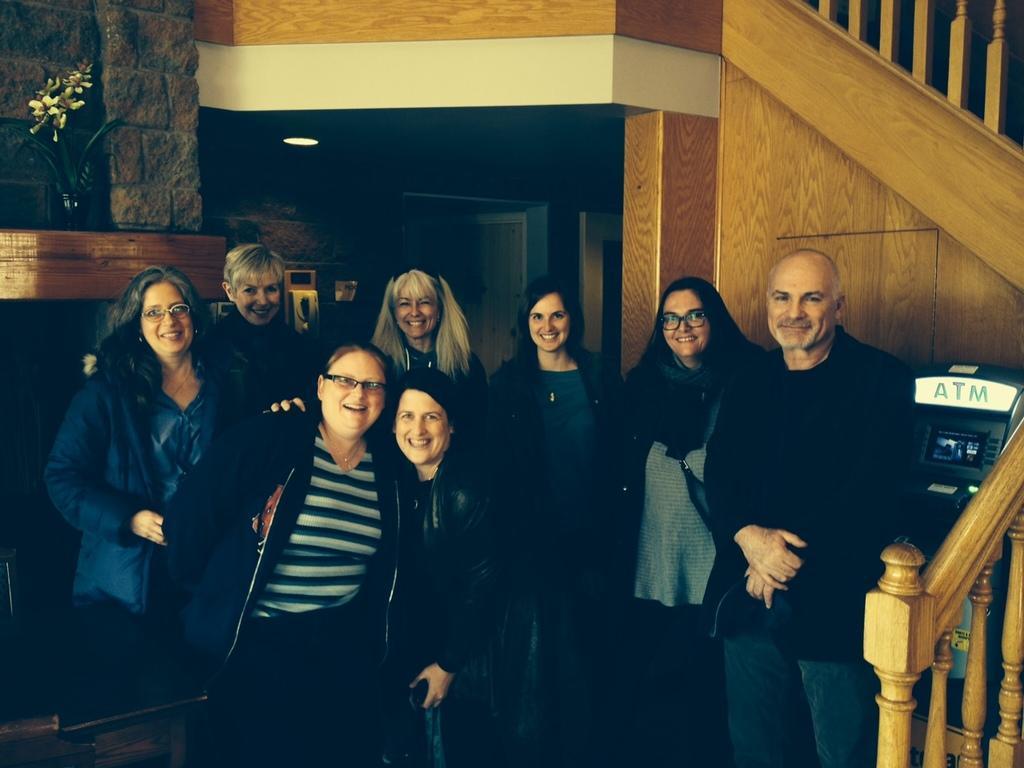Can you describe this image briefly? In this image we can see the stairs. And we can see a few people standing. And we can see the ATM machine. And we can see the lights, doors. And we can see the flower vase and some other objects. 